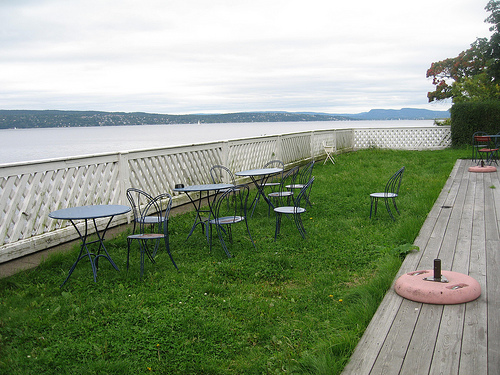<image>
Can you confirm if the fence is behind the table? Yes. From this viewpoint, the fence is positioned behind the table, with the table partially or fully occluding the fence. 